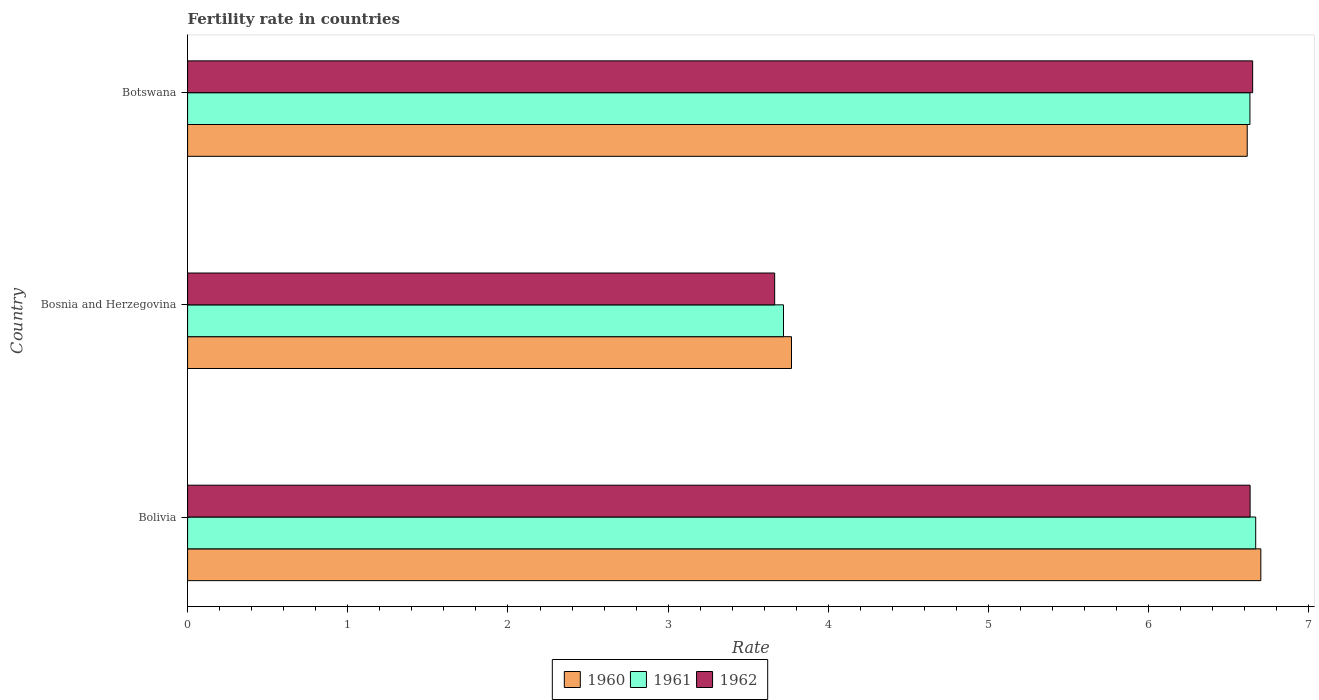How many bars are there on the 1st tick from the top?
Provide a succinct answer. 3. What is the label of the 1st group of bars from the top?
Ensure brevity in your answer.  Botswana. What is the fertility rate in 1961 in Bosnia and Herzegovina?
Offer a terse response. 3.72. Across all countries, what is the maximum fertility rate in 1961?
Keep it short and to the point. 6.67. Across all countries, what is the minimum fertility rate in 1960?
Your response must be concise. 3.77. In which country was the fertility rate in 1962 maximum?
Make the answer very short. Botswana. In which country was the fertility rate in 1960 minimum?
Provide a succinct answer. Bosnia and Herzegovina. What is the total fertility rate in 1960 in the graph?
Keep it short and to the point. 17.09. What is the difference between the fertility rate in 1961 in Bolivia and that in Bosnia and Herzegovina?
Offer a very short reply. 2.95. What is the difference between the fertility rate in 1960 in Bolivia and the fertility rate in 1961 in Bosnia and Herzegovina?
Provide a short and direct response. 2.98. What is the average fertility rate in 1962 per country?
Give a very brief answer. 5.65. What is the difference between the fertility rate in 1962 and fertility rate in 1960 in Botswana?
Make the answer very short. 0.03. In how many countries, is the fertility rate in 1960 greater than 5.6 ?
Keep it short and to the point. 2. What is the ratio of the fertility rate in 1960 in Bolivia to that in Bosnia and Herzegovina?
Provide a succinct answer. 1.78. Is the fertility rate in 1962 in Bolivia less than that in Bosnia and Herzegovina?
Give a very brief answer. No. What is the difference between the highest and the second highest fertility rate in 1961?
Offer a terse response. 0.04. What is the difference between the highest and the lowest fertility rate in 1960?
Your answer should be very brief. 2.93. What does the 2nd bar from the top in Botswana represents?
Provide a succinct answer. 1961. What does the 3rd bar from the bottom in Botswana represents?
Provide a succinct answer. 1962. Is it the case that in every country, the sum of the fertility rate in 1960 and fertility rate in 1962 is greater than the fertility rate in 1961?
Provide a succinct answer. Yes. How many countries are there in the graph?
Your response must be concise. 3. What is the difference between two consecutive major ticks on the X-axis?
Ensure brevity in your answer.  1. Does the graph contain grids?
Your response must be concise. No. Where does the legend appear in the graph?
Provide a short and direct response. Bottom center. How many legend labels are there?
Ensure brevity in your answer.  3. What is the title of the graph?
Offer a terse response. Fertility rate in countries. What is the label or title of the X-axis?
Make the answer very short. Rate. What is the label or title of the Y-axis?
Offer a very short reply. Country. What is the Rate in 1961 in Bolivia?
Keep it short and to the point. 6.67. What is the Rate in 1962 in Bolivia?
Your answer should be very brief. 6.63. What is the Rate of 1960 in Bosnia and Herzegovina?
Make the answer very short. 3.77. What is the Rate in 1961 in Bosnia and Herzegovina?
Your answer should be very brief. 3.72. What is the Rate of 1962 in Bosnia and Herzegovina?
Provide a succinct answer. 3.67. What is the Rate in 1960 in Botswana?
Offer a very short reply. 6.62. What is the Rate in 1961 in Botswana?
Ensure brevity in your answer.  6.63. What is the Rate of 1962 in Botswana?
Keep it short and to the point. 6.65. Across all countries, what is the maximum Rate of 1960?
Make the answer very short. 6.7. Across all countries, what is the maximum Rate of 1961?
Provide a succinct answer. 6.67. Across all countries, what is the maximum Rate in 1962?
Make the answer very short. 6.65. Across all countries, what is the minimum Rate of 1960?
Ensure brevity in your answer.  3.77. Across all countries, what is the minimum Rate in 1961?
Offer a terse response. 3.72. Across all countries, what is the minimum Rate of 1962?
Your answer should be compact. 3.67. What is the total Rate of 1960 in the graph?
Give a very brief answer. 17.09. What is the total Rate of 1961 in the graph?
Give a very brief answer. 17.02. What is the total Rate of 1962 in the graph?
Offer a very short reply. 16.95. What is the difference between the Rate of 1960 in Bolivia and that in Bosnia and Herzegovina?
Keep it short and to the point. 2.93. What is the difference between the Rate in 1961 in Bolivia and that in Bosnia and Herzegovina?
Ensure brevity in your answer.  2.95. What is the difference between the Rate in 1962 in Bolivia and that in Bosnia and Herzegovina?
Make the answer very short. 2.97. What is the difference between the Rate in 1960 in Bolivia and that in Botswana?
Provide a succinct answer. 0.09. What is the difference between the Rate of 1961 in Bolivia and that in Botswana?
Your response must be concise. 0.04. What is the difference between the Rate of 1962 in Bolivia and that in Botswana?
Make the answer very short. -0.02. What is the difference between the Rate in 1960 in Bosnia and Herzegovina and that in Botswana?
Your response must be concise. -2.85. What is the difference between the Rate in 1961 in Bosnia and Herzegovina and that in Botswana?
Offer a very short reply. -2.91. What is the difference between the Rate in 1962 in Bosnia and Herzegovina and that in Botswana?
Ensure brevity in your answer.  -2.98. What is the difference between the Rate of 1960 in Bolivia and the Rate of 1961 in Bosnia and Herzegovina?
Ensure brevity in your answer.  2.98. What is the difference between the Rate of 1960 in Bolivia and the Rate of 1962 in Bosnia and Herzegovina?
Provide a short and direct response. 3.04. What is the difference between the Rate of 1961 in Bolivia and the Rate of 1962 in Bosnia and Herzegovina?
Provide a succinct answer. 3. What is the difference between the Rate in 1960 in Bolivia and the Rate in 1961 in Botswana?
Keep it short and to the point. 0.07. What is the difference between the Rate of 1960 in Bolivia and the Rate of 1962 in Botswana?
Offer a terse response. 0.05. What is the difference between the Rate in 1961 in Bolivia and the Rate in 1962 in Botswana?
Provide a short and direct response. 0.02. What is the difference between the Rate in 1960 in Bosnia and Herzegovina and the Rate in 1961 in Botswana?
Your answer should be compact. -2.86. What is the difference between the Rate of 1960 in Bosnia and Herzegovina and the Rate of 1962 in Botswana?
Give a very brief answer. -2.88. What is the difference between the Rate of 1961 in Bosnia and Herzegovina and the Rate of 1962 in Botswana?
Give a very brief answer. -2.93. What is the average Rate of 1960 per country?
Your response must be concise. 5.7. What is the average Rate in 1961 per country?
Provide a short and direct response. 5.67. What is the average Rate of 1962 per country?
Your answer should be compact. 5.65. What is the difference between the Rate of 1960 and Rate of 1961 in Bolivia?
Keep it short and to the point. 0.03. What is the difference between the Rate of 1960 and Rate of 1962 in Bolivia?
Provide a short and direct response. 0.07. What is the difference between the Rate of 1961 and Rate of 1962 in Bolivia?
Make the answer very short. 0.04. What is the difference between the Rate in 1960 and Rate in 1962 in Bosnia and Herzegovina?
Provide a succinct answer. 0.1. What is the difference between the Rate of 1961 and Rate of 1962 in Bosnia and Herzegovina?
Give a very brief answer. 0.06. What is the difference between the Rate of 1960 and Rate of 1961 in Botswana?
Keep it short and to the point. -0.02. What is the difference between the Rate in 1960 and Rate in 1962 in Botswana?
Keep it short and to the point. -0.03. What is the difference between the Rate in 1961 and Rate in 1962 in Botswana?
Offer a very short reply. -0.02. What is the ratio of the Rate of 1960 in Bolivia to that in Bosnia and Herzegovina?
Your answer should be very brief. 1.78. What is the ratio of the Rate in 1961 in Bolivia to that in Bosnia and Herzegovina?
Provide a succinct answer. 1.79. What is the ratio of the Rate in 1962 in Bolivia to that in Bosnia and Herzegovina?
Your answer should be compact. 1.81. What is the ratio of the Rate of 1960 in Bolivia to that in Botswana?
Your answer should be compact. 1.01. What is the ratio of the Rate of 1961 in Bolivia to that in Botswana?
Provide a short and direct response. 1.01. What is the ratio of the Rate of 1960 in Bosnia and Herzegovina to that in Botswana?
Keep it short and to the point. 0.57. What is the ratio of the Rate of 1961 in Bosnia and Herzegovina to that in Botswana?
Make the answer very short. 0.56. What is the ratio of the Rate in 1962 in Bosnia and Herzegovina to that in Botswana?
Give a very brief answer. 0.55. What is the difference between the highest and the second highest Rate of 1960?
Offer a very short reply. 0.09. What is the difference between the highest and the second highest Rate in 1961?
Your answer should be compact. 0.04. What is the difference between the highest and the second highest Rate in 1962?
Make the answer very short. 0.02. What is the difference between the highest and the lowest Rate of 1960?
Ensure brevity in your answer.  2.93. What is the difference between the highest and the lowest Rate of 1961?
Make the answer very short. 2.95. What is the difference between the highest and the lowest Rate in 1962?
Keep it short and to the point. 2.98. 